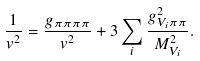<formula> <loc_0><loc_0><loc_500><loc_500>\frac { 1 } { v ^ { 2 } } = \frac { g _ { \pi \pi \pi \pi } } { v ^ { 2 } } + 3 \sum _ { i } \frac { g _ { V _ { i } \pi \pi } ^ { 2 } } { M _ { V _ { i } } ^ { 2 } } .</formula> 